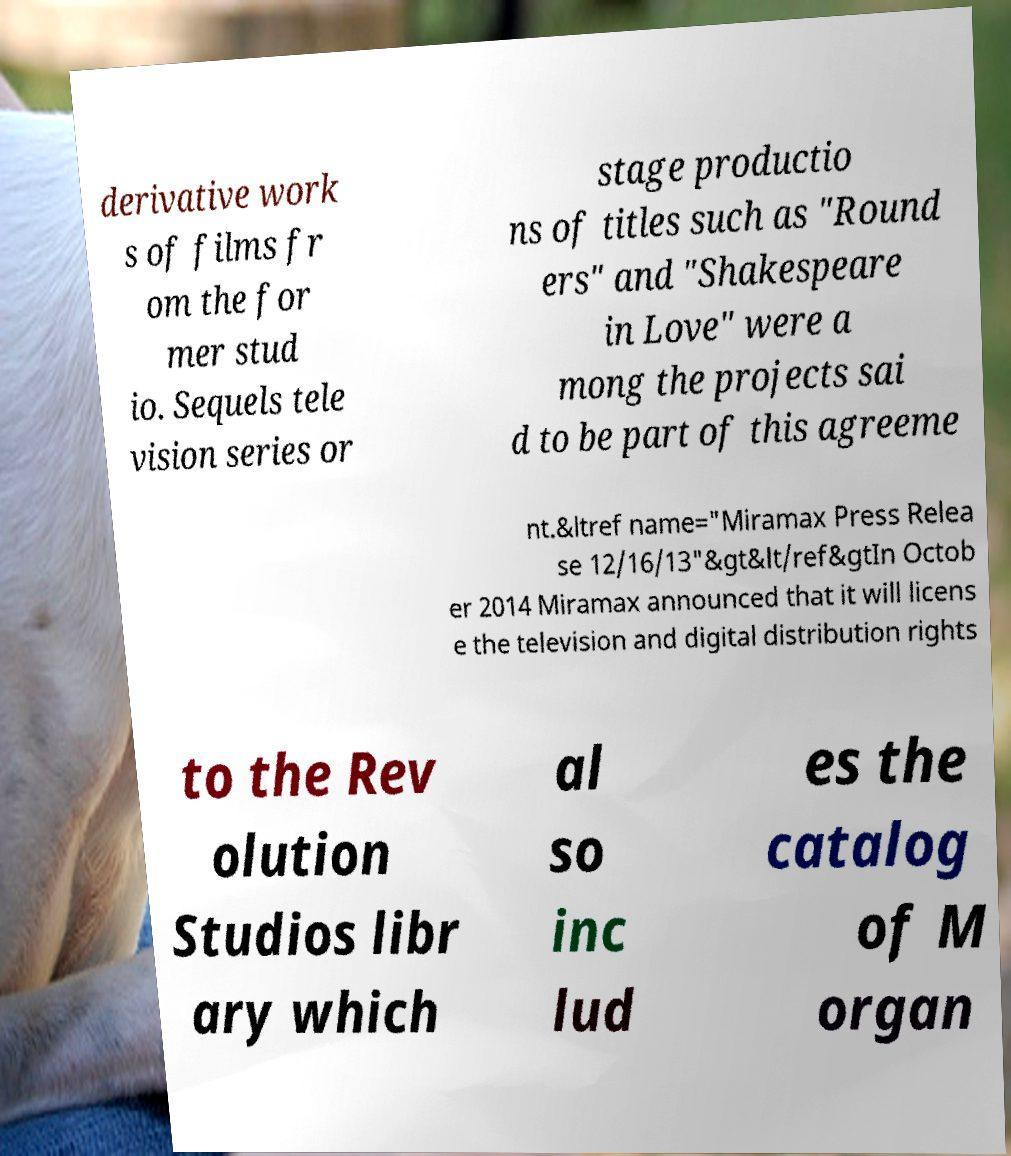Could you assist in decoding the text presented in this image and type it out clearly? derivative work s of films fr om the for mer stud io. Sequels tele vision series or stage productio ns of titles such as "Round ers" and "Shakespeare in Love" were a mong the projects sai d to be part of this agreeme nt.&ltref name="Miramax Press Relea se 12/16/13"&gt&lt/ref&gtIn Octob er 2014 Miramax announced that it will licens e the television and digital distribution rights to the Rev olution Studios libr ary which al so inc lud es the catalog of M organ 